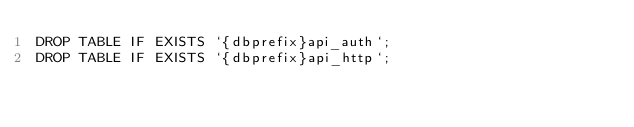<code> <loc_0><loc_0><loc_500><loc_500><_SQL_>DROP TABLE IF EXISTS `{dbprefix}api_auth`;
DROP TABLE IF EXISTS `{dbprefix}api_http`;

</code> 